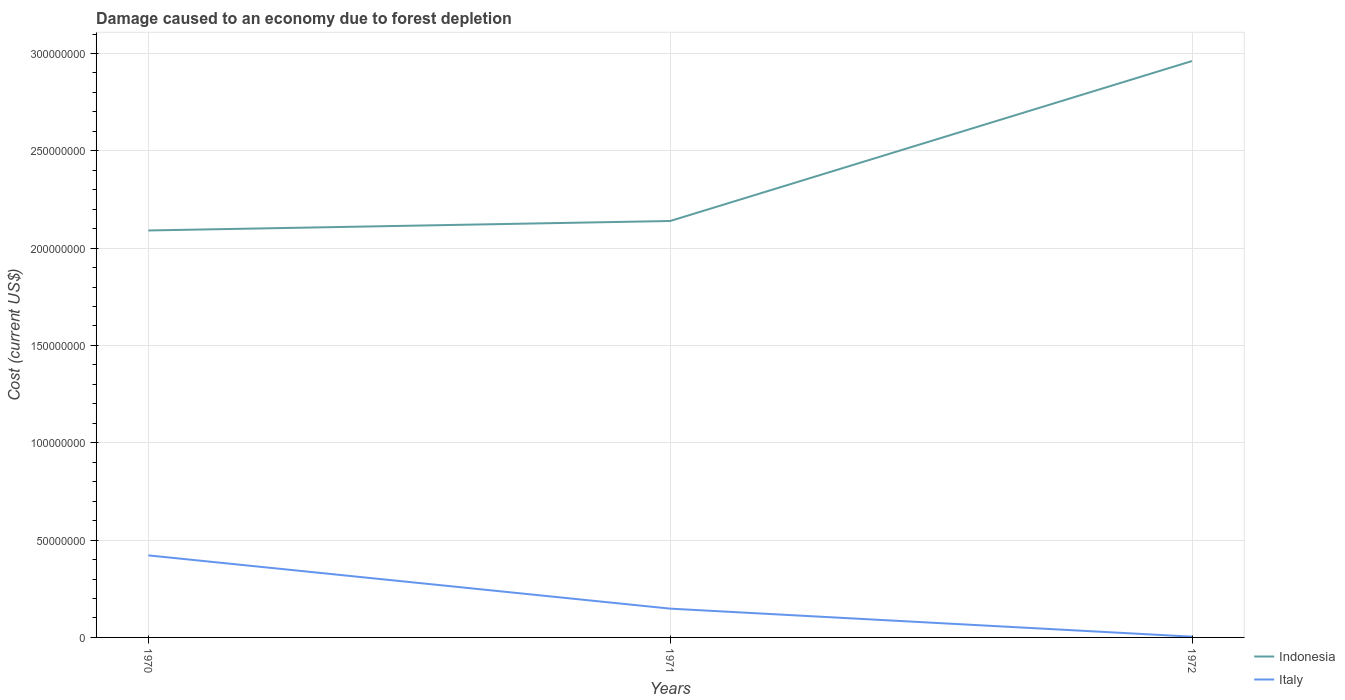How many different coloured lines are there?
Give a very brief answer. 2. Does the line corresponding to Italy intersect with the line corresponding to Indonesia?
Keep it short and to the point. No. Across all years, what is the maximum cost of damage caused due to forest depletion in Indonesia?
Provide a short and direct response. 2.09e+08. In which year was the cost of damage caused due to forest depletion in Italy maximum?
Your answer should be compact. 1972. What is the total cost of damage caused due to forest depletion in Indonesia in the graph?
Your answer should be very brief. -4.86e+06. What is the difference between the highest and the second highest cost of damage caused due to forest depletion in Italy?
Make the answer very short. 4.18e+07. What is the difference between the highest and the lowest cost of damage caused due to forest depletion in Italy?
Provide a succinct answer. 1. Are the values on the major ticks of Y-axis written in scientific E-notation?
Give a very brief answer. No. Does the graph contain any zero values?
Your answer should be very brief. No. Does the graph contain grids?
Keep it short and to the point. Yes. How are the legend labels stacked?
Keep it short and to the point. Vertical. What is the title of the graph?
Offer a terse response. Damage caused to an economy due to forest depletion. Does "Mauritius" appear as one of the legend labels in the graph?
Your answer should be compact. No. What is the label or title of the Y-axis?
Your answer should be compact. Cost (current US$). What is the Cost (current US$) of Indonesia in 1970?
Your answer should be compact. 2.09e+08. What is the Cost (current US$) in Italy in 1970?
Offer a very short reply. 4.22e+07. What is the Cost (current US$) of Indonesia in 1971?
Your answer should be very brief. 2.14e+08. What is the Cost (current US$) of Italy in 1971?
Your answer should be compact. 1.48e+07. What is the Cost (current US$) in Indonesia in 1972?
Ensure brevity in your answer.  2.96e+08. What is the Cost (current US$) of Italy in 1972?
Offer a very short reply. 3.87e+05. Across all years, what is the maximum Cost (current US$) in Indonesia?
Your answer should be very brief. 2.96e+08. Across all years, what is the maximum Cost (current US$) of Italy?
Provide a short and direct response. 4.22e+07. Across all years, what is the minimum Cost (current US$) of Indonesia?
Your answer should be compact. 2.09e+08. Across all years, what is the minimum Cost (current US$) of Italy?
Provide a short and direct response. 3.87e+05. What is the total Cost (current US$) of Indonesia in the graph?
Provide a succinct answer. 7.19e+08. What is the total Cost (current US$) in Italy in the graph?
Keep it short and to the point. 5.73e+07. What is the difference between the Cost (current US$) in Indonesia in 1970 and that in 1971?
Offer a terse response. -4.86e+06. What is the difference between the Cost (current US$) of Italy in 1970 and that in 1971?
Offer a terse response. 2.74e+07. What is the difference between the Cost (current US$) in Indonesia in 1970 and that in 1972?
Ensure brevity in your answer.  -8.70e+07. What is the difference between the Cost (current US$) of Italy in 1970 and that in 1972?
Your answer should be compact. 4.18e+07. What is the difference between the Cost (current US$) of Indonesia in 1971 and that in 1972?
Ensure brevity in your answer.  -8.22e+07. What is the difference between the Cost (current US$) in Italy in 1971 and that in 1972?
Your answer should be compact. 1.44e+07. What is the difference between the Cost (current US$) of Indonesia in 1970 and the Cost (current US$) of Italy in 1971?
Provide a short and direct response. 1.94e+08. What is the difference between the Cost (current US$) in Indonesia in 1970 and the Cost (current US$) in Italy in 1972?
Offer a terse response. 2.09e+08. What is the difference between the Cost (current US$) in Indonesia in 1971 and the Cost (current US$) in Italy in 1972?
Keep it short and to the point. 2.14e+08. What is the average Cost (current US$) of Indonesia per year?
Ensure brevity in your answer.  2.40e+08. What is the average Cost (current US$) of Italy per year?
Keep it short and to the point. 1.91e+07. In the year 1970, what is the difference between the Cost (current US$) in Indonesia and Cost (current US$) in Italy?
Provide a succinct answer. 1.67e+08. In the year 1971, what is the difference between the Cost (current US$) in Indonesia and Cost (current US$) in Italy?
Keep it short and to the point. 1.99e+08. In the year 1972, what is the difference between the Cost (current US$) of Indonesia and Cost (current US$) of Italy?
Offer a terse response. 2.96e+08. What is the ratio of the Cost (current US$) in Indonesia in 1970 to that in 1971?
Give a very brief answer. 0.98. What is the ratio of the Cost (current US$) in Italy in 1970 to that in 1971?
Your response must be concise. 2.85. What is the ratio of the Cost (current US$) of Indonesia in 1970 to that in 1972?
Make the answer very short. 0.71. What is the ratio of the Cost (current US$) of Italy in 1970 to that in 1972?
Provide a short and direct response. 108.87. What is the ratio of the Cost (current US$) of Indonesia in 1971 to that in 1972?
Keep it short and to the point. 0.72. What is the ratio of the Cost (current US$) in Italy in 1971 to that in 1972?
Offer a terse response. 38.2. What is the difference between the highest and the second highest Cost (current US$) in Indonesia?
Offer a very short reply. 8.22e+07. What is the difference between the highest and the second highest Cost (current US$) of Italy?
Keep it short and to the point. 2.74e+07. What is the difference between the highest and the lowest Cost (current US$) in Indonesia?
Your answer should be compact. 8.70e+07. What is the difference between the highest and the lowest Cost (current US$) in Italy?
Offer a terse response. 4.18e+07. 